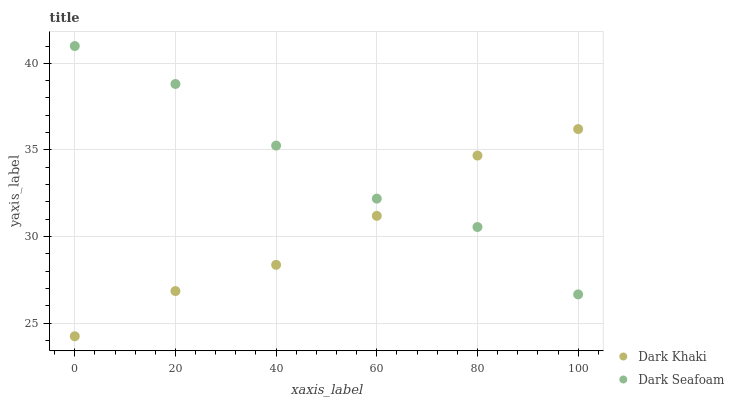Does Dark Khaki have the minimum area under the curve?
Answer yes or no. Yes. Does Dark Seafoam have the maximum area under the curve?
Answer yes or no. Yes. Does Dark Seafoam have the minimum area under the curve?
Answer yes or no. No. Is Dark Khaki the smoothest?
Answer yes or no. Yes. Is Dark Seafoam the roughest?
Answer yes or no. Yes. Is Dark Seafoam the smoothest?
Answer yes or no. No. Does Dark Khaki have the lowest value?
Answer yes or no. Yes. Does Dark Seafoam have the lowest value?
Answer yes or no. No. Does Dark Seafoam have the highest value?
Answer yes or no. Yes. Does Dark Khaki intersect Dark Seafoam?
Answer yes or no. Yes. Is Dark Khaki less than Dark Seafoam?
Answer yes or no. No. Is Dark Khaki greater than Dark Seafoam?
Answer yes or no. No. 